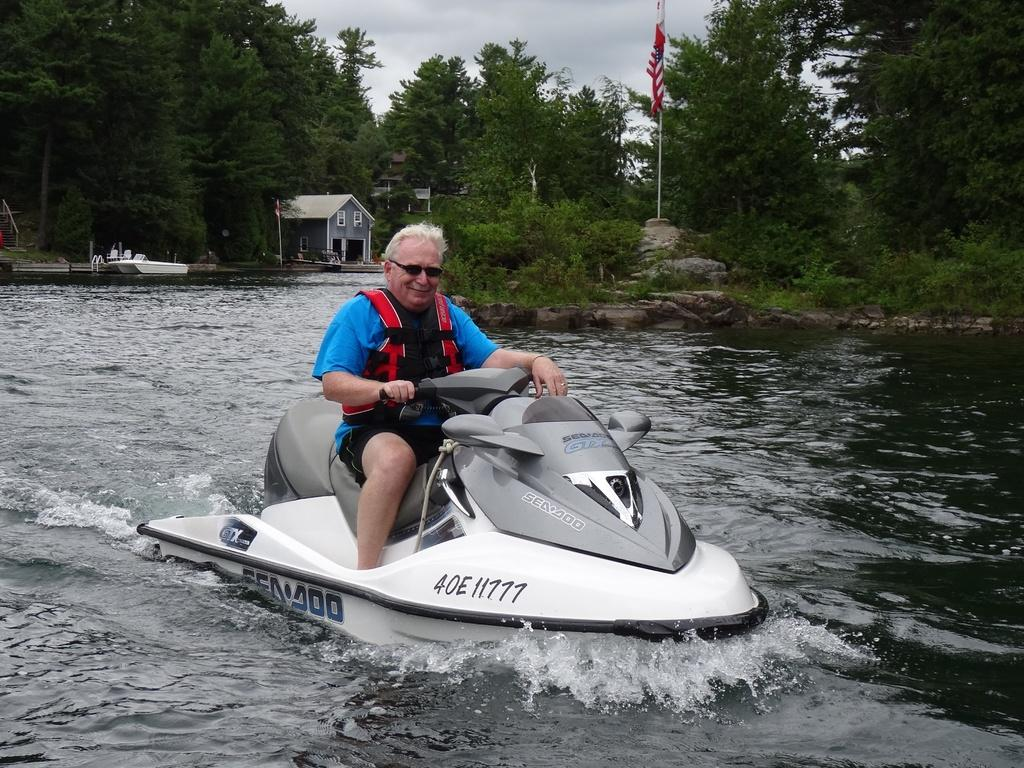<image>
Summarize the visual content of the image. A man in a blue shirt is riding a white Sea Doo waverunner. 